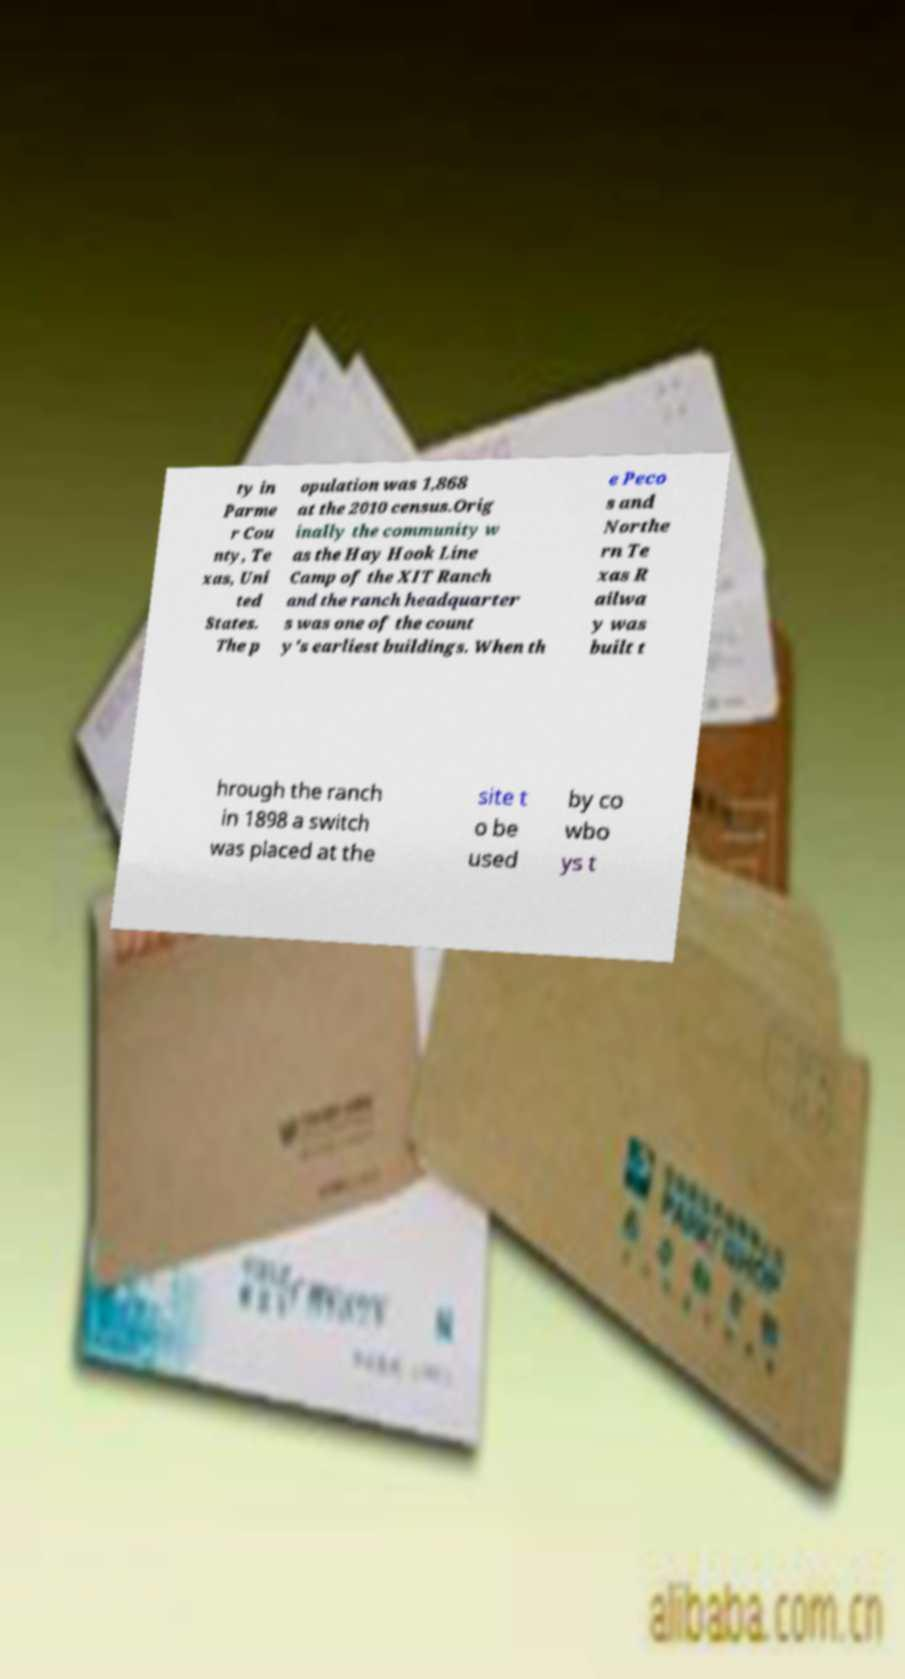For documentation purposes, I need the text within this image transcribed. Could you provide that? ty in Parme r Cou nty, Te xas, Uni ted States. The p opulation was 1,868 at the 2010 census.Orig inally the community w as the Hay Hook Line Camp of the XIT Ranch and the ranch headquarter s was one of the count y's earliest buildings. When th e Peco s and Northe rn Te xas R ailwa y was built t hrough the ranch in 1898 a switch was placed at the site t o be used by co wbo ys t 